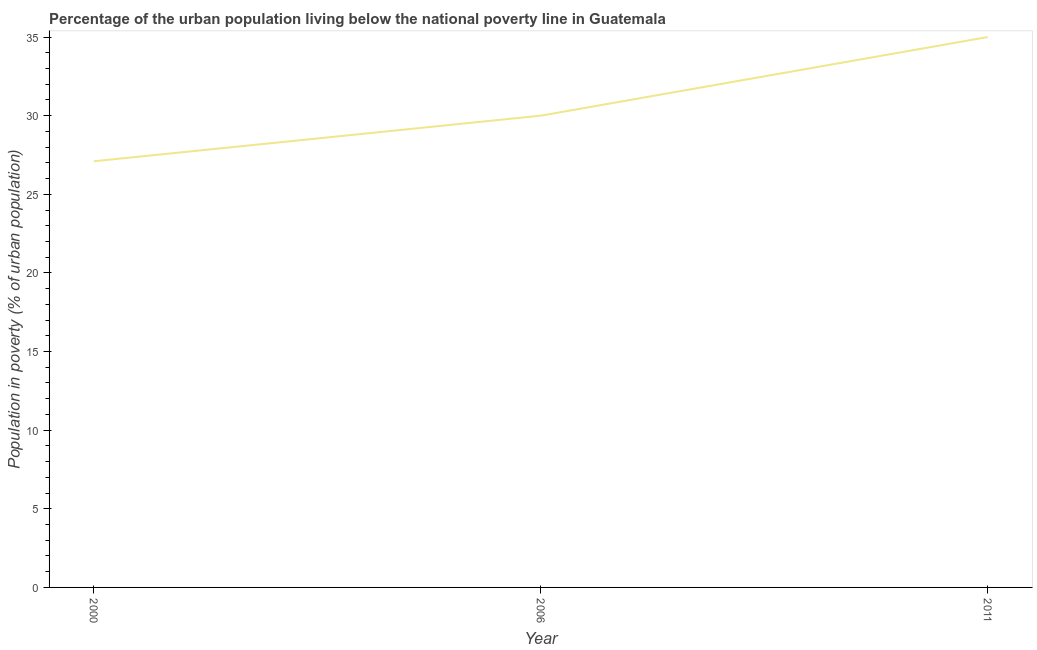What is the percentage of urban population living below poverty line in 2006?
Give a very brief answer. 30. Across all years, what is the minimum percentage of urban population living below poverty line?
Ensure brevity in your answer.  27.1. In which year was the percentage of urban population living below poverty line maximum?
Offer a very short reply. 2011. In which year was the percentage of urban population living below poverty line minimum?
Keep it short and to the point. 2000. What is the sum of the percentage of urban population living below poverty line?
Ensure brevity in your answer.  92.1. What is the difference between the percentage of urban population living below poverty line in 2000 and 2011?
Give a very brief answer. -7.9. What is the average percentage of urban population living below poverty line per year?
Make the answer very short. 30.7. What is the median percentage of urban population living below poverty line?
Make the answer very short. 30. In how many years, is the percentage of urban population living below poverty line greater than 11 %?
Keep it short and to the point. 3. What is the ratio of the percentage of urban population living below poverty line in 2000 to that in 2011?
Your answer should be very brief. 0.77. Is the percentage of urban population living below poverty line in 2000 less than that in 2006?
Your answer should be compact. Yes. Is the sum of the percentage of urban population living below poverty line in 2000 and 2011 greater than the maximum percentage of urban population living below poverty line across all years?
Offer a terse response. Yes. What is the difference between the highest and the lowest percentage of urban population living below poverty line?
Make the answer very short. 7.9. In how many years, is the percentage of urban population living below poverty line greater than the average percentage of urban population living below poverty line taken over all years?
Your answer should be compact. 1. How many lines are there?
Offer a terse response. 1. Are the values on the major ticks of Y-axis written in scientific E-notation?
Keep it short and to the point. No. Does the graph contain grids?
Keep it short and to the point. No. What is the title of the graph?
Your answer should be compact. Percentage of the urban population living below the national poverty line in Guatemala. What is the label or title of the X-axis?
Give a very brief answer. Year. What is the label or title of the Y-axis?
Offer a terse response. Population in poverty (% of urban population). What is the Population in poverty (% of urban population) in 2000?
Offer a terse response. 27.1. What is the Population in poverty (% of urban population) of 2006?
Offer a terse response. 30. What is the Population in poverty (% of urban population) of 2011?
Offer a very short reply. 35. What is the difference between the Population in poverty (% of urban population) in 2006 and 2011?
Your answer should be compact. -5. What is the ratio of the Population in poverty (% of urban population) in 2000 to that in 2006?
Your answer should be compact. 0.9. What is the ratio of the Population in poverty (% of urban population) in 2000 to that in 2011?
Ensure brevity in your answer.  0.77. What is the ratio of the Population in poverty (% of urban population) in 2006 to that in 2011?
Your answer should be compact. 0.86. 